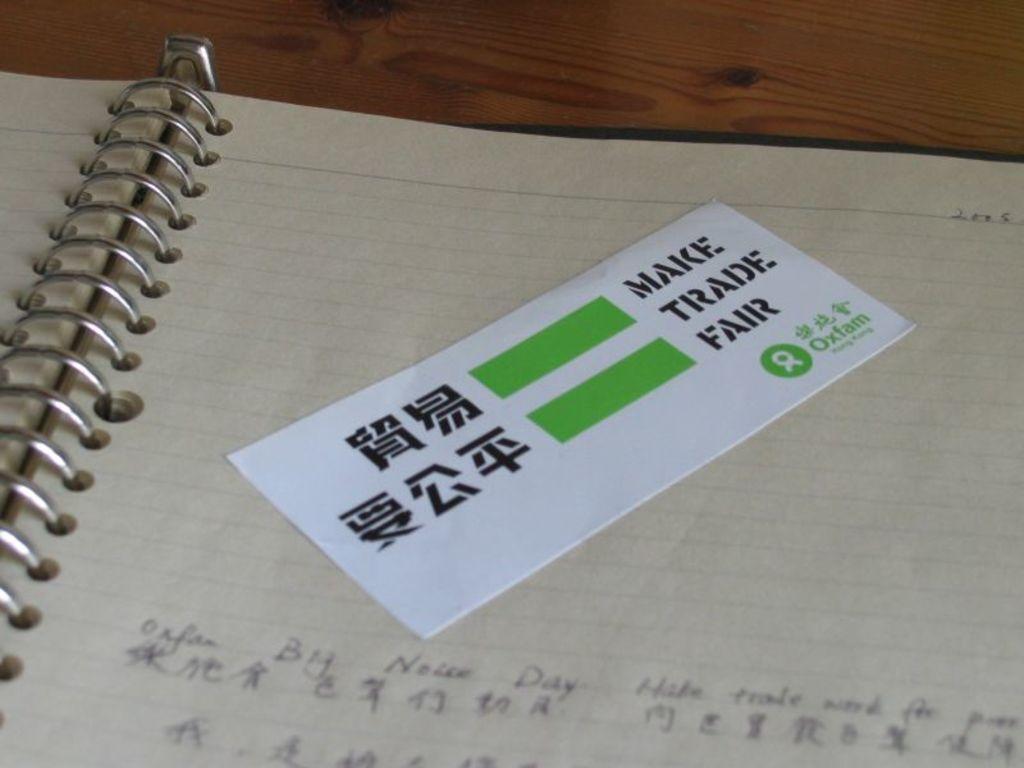What should be fair?
Your answer should be compact. Trade. What is the hope of the message on the card?
Ensure brevity in your answer.  Make trade fair. 